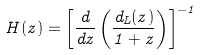Convert formula to latex. <formula><loc_0><loc_0><loc_500><loc_500>H ( z ) = \left [ \frac { d } { d z } \left ( \frac { d _ { L } ( z ) } { 1 + z } \right ) \right ] ^ { - 1 }</formula> 